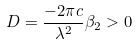<formula> <loc_0><loc_0><loc_500><loc_500>D = \frac { - 2 \pi c } { \lambda ^ { 2 } } \beta _ { 2 } > 0</formula> 